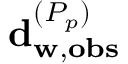<formula> <loc_0><loc_0><loc_500><loc_500>d _ { w , o b s } ^ { ( P _ { p } ) }</formula> 